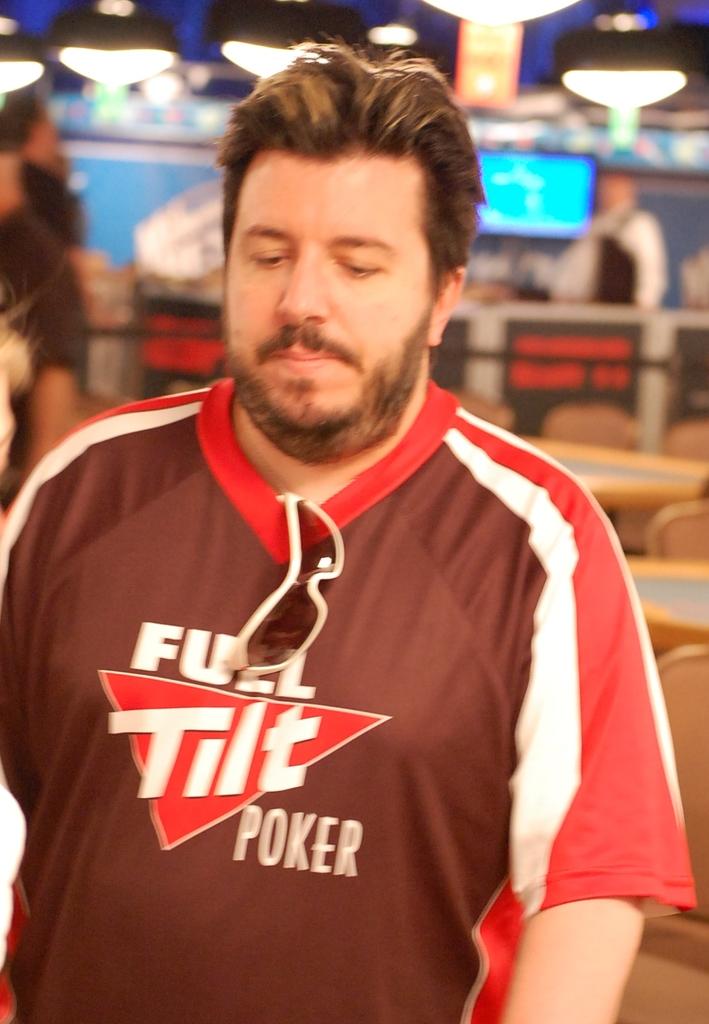What is written on his shirt?
Ensure brevity in your answer.  Full tilt poker. 